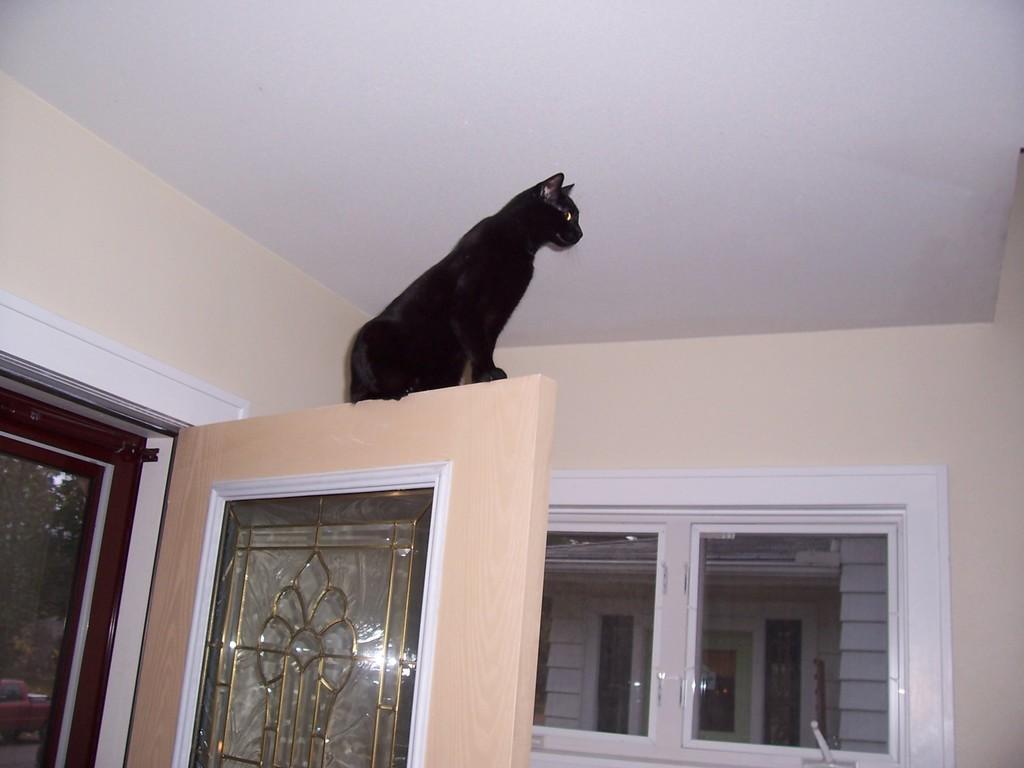Could you give a brief overview of what you see in this image? In this room we can see a black cat sitting on a door and we can also see a wall and windows. Through the window glass door we can see a building and through the mesh door on the left side we can see trees and a vehicle on the road. 